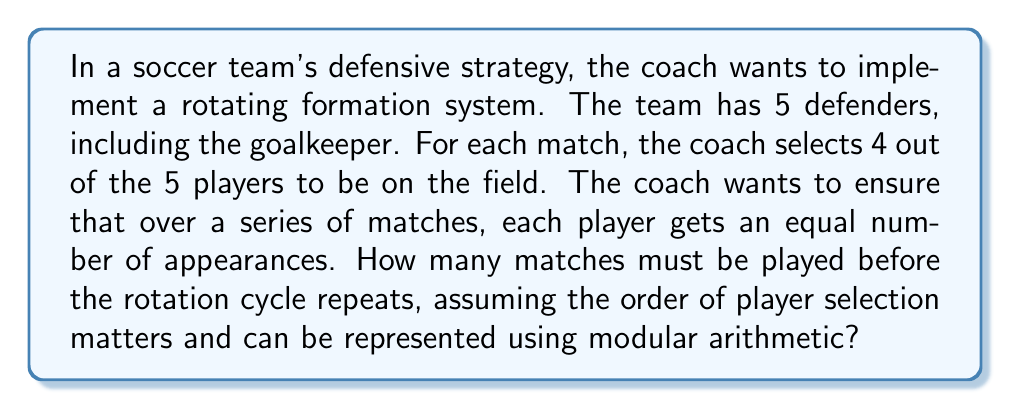Give your solution to this math problem. Let's approach this step-by-step:

1) First, we need to calculate the number of possible arrangements of 4 players out of 5:
   This is a permutation problem, represented as $P(5,4)$

2) The formula for this permutation is:
   $$P(5,4) = \frac{5!}{(5-4)!} = \frac{5!}{1!}$$

3) Let's calculate this:
   $$\frac{5 * 4 * 3 * 2 * 1}{1} = 120$$

4) So there are 120 possible arrangements of 4 players out of 5.

5) In modular arithmetic, this means we're working in mod 120.

6) For the rotation cycle to repeat, each player must have appeared an equal number of times.

7) The number of appearances for each player must be divisible by 4 (as 4 players are selected each time).

8) The smallest number that is both divisible by 120 (to complete the cycle) and by 4 (for equal appearances) is 120 itself.

9) Therefore, the rotation cycle will repeat after 120 matches.

10) We can verify: In 120 matches, each player will appear 96 times (120 * 4 / 5), which is indeed divisible by 4.
Answer: 120 matches 